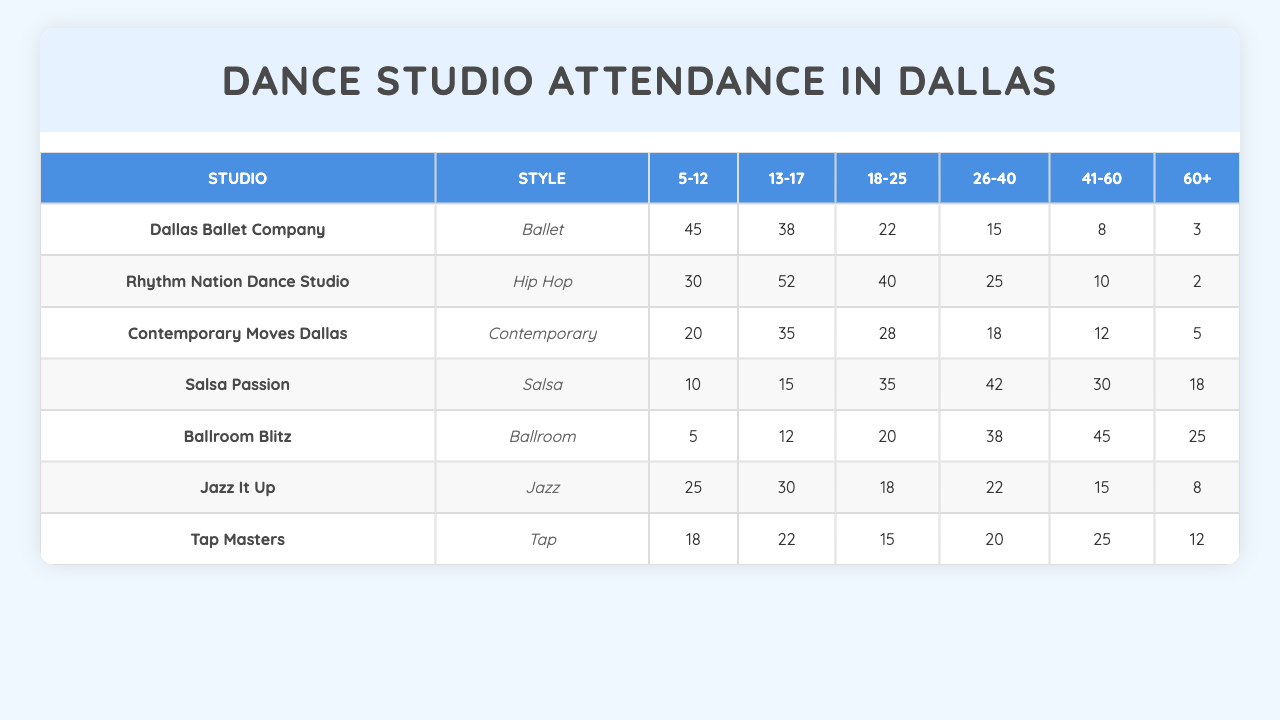What dance style has the highest attendance rate among the 5-12 age group? By looking at the first column under the "5-12" heading, we can see that the highest attendance rate is 45 for the Ballet style at Dallas Ballet Company.
Answer: Ballet Which age group has the lowest attendance for the Hip Hop dance style? In the Hip Hop section, the 60+ age group has the lowest attendance rate with only 2 participants.
Answer: 60+ What is the total attendance for Salsa dance classes in the 41-60 age group? For Salsa, the attendance for the 41-60 age group is 30. There are no additional calculations needed since we're looking for a specific value.
Answer: 30 What is the average attendance for the 26-40 age group across all dance styles? The attendance for the 26-40 age group across all studios is (15 + 25 + 18 + 42 + 38 + 22 + 20) = 180. To find the average, divide this sum by the number of styles (7), which gives us 180/7 ≈ 25.71.
Answer: 25.71 Is the attendance rate for the 13-17 age group in Jazz It Up higher than in Contemporary Moves Dallas? Jazz It Up has an attendance rate of 30 for the 13-17 age group, while Contemporary Moves Dallas has a rate of 35. Since 30 is lower than 35, the statement is false.
Answer: No What is the difference in attendance for the 18-25 age group between Salsa Passion and Ballroom Blitz? The attendance for Salsa Passion in the 18-25 age group is 35, while for Ballroom Blitz it is 20. The difference is found by subtracting 20 from 35, which gives us 15.
Answer: 15 Which dance studio has the lowest total attendance across all age groups? We sum the attendance for each studio: Dallas Ballet Company (131), Rhythm Nation Dance Studio (157), Contemporary Moves Dallas (118), Salsa Passion (130), Ballroom Blitz (150), Jazz It Up (118), and Tap Masters (112). The lowest total is for Tap Masters at 112.
Answer: Tap Masters What is the highest attendance rate recorded for the 60+ age group among all dance styles? By checking the last column under the "60+" heading, the highest attendance rate is 25 from Ballroom Blitz.
Answer: 25 How does the attendance of 18-25 year-olds in Rhythm Nation compare to that in Jazz It Up? In Rhythm Nation, the attendance for the 18-25 age group is 40, while in Jazz It Up it is 18. The first is significantly higher than the latter.
Answer: Higher Does the 5-12 age group show a greater total attendance in the Contemporary style compared to Ballet? For Contemporary, the 5-12 age group has 20 attendees, while Ballet has 45. Since 20 is less than 45, this statement is false.
Answer: No 